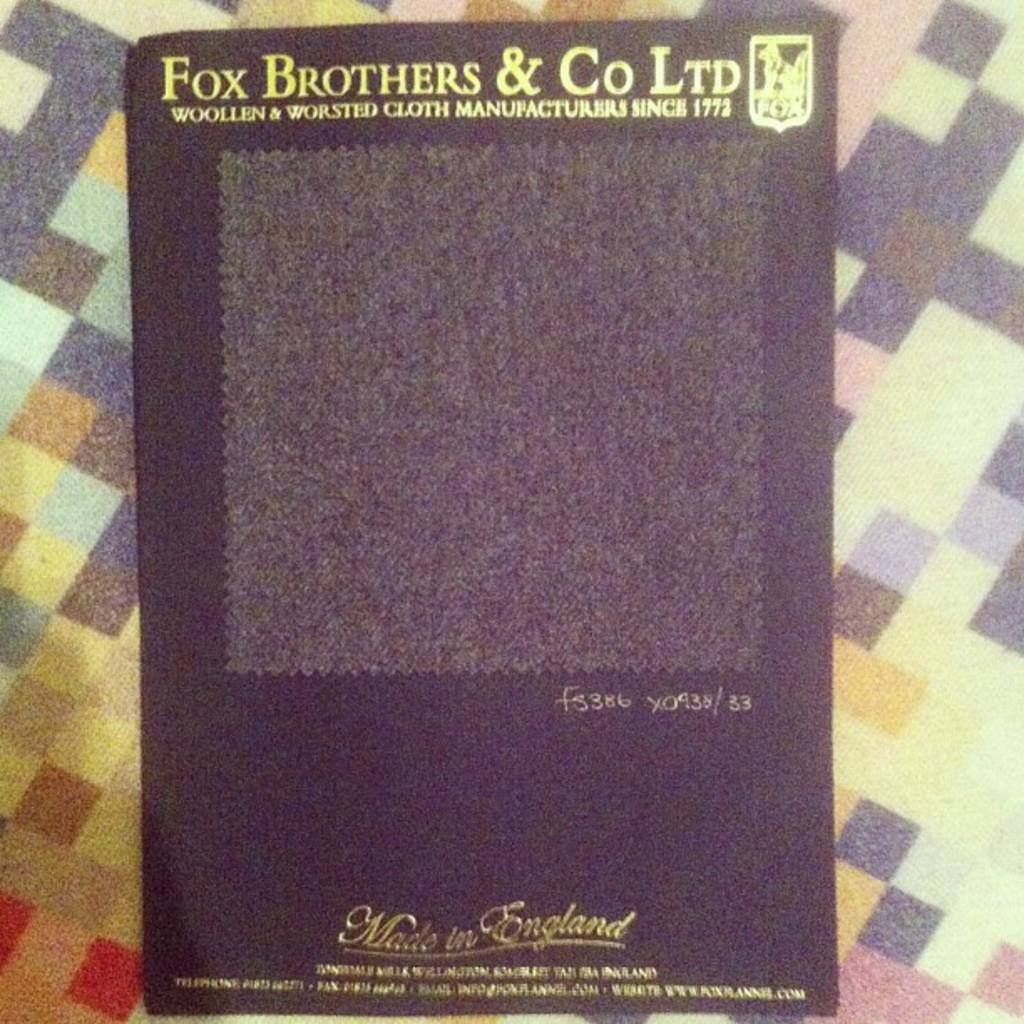Provide a one-sentence caption for the provided image. A package of English made cloth is sold by Fox Brothers and Company. 